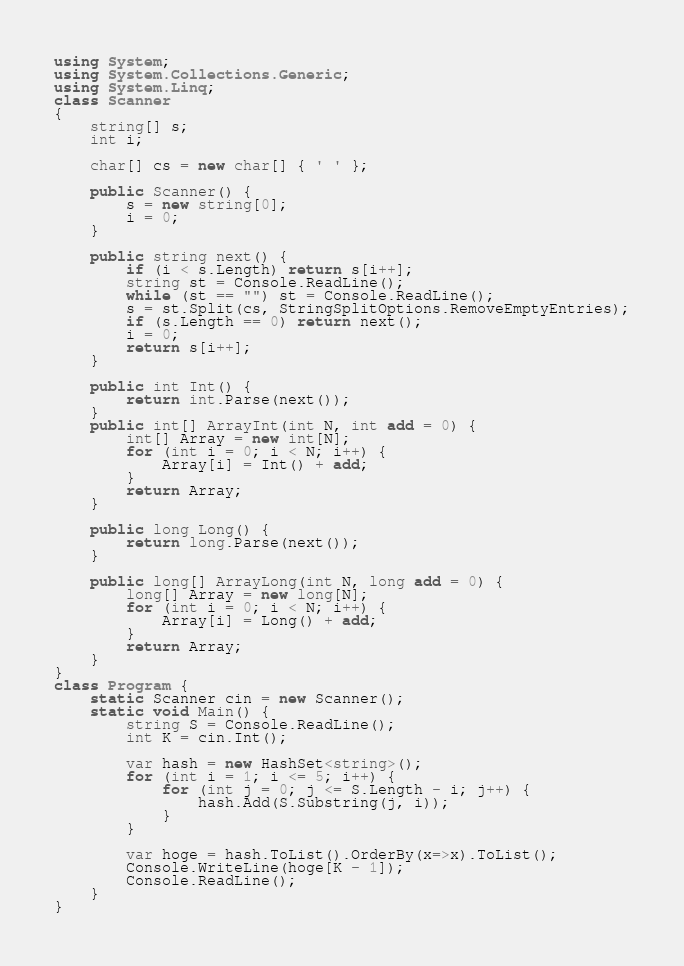Convert code to text. <code><loc_0><loc_0><loc_500><loc_500><_C#_>using System;
using System.Collections.Generic;
using System.Linq;
class Scanner
{
    string[] s;
    int i;

    char[] cs = new char[] { ' ' };

    public Scanner() {
        s = new string[0];
        i = 0;
    }

    public string next() {
        if (i < s.Length) return s[i++];
        string st = Console.ReadLine();
        while (st == "") st = Console.ReadLine();
        s = st.Split(cs, StringSplitOptions.RemoveEmptyEntries);
        if (s.Length == 0) return next();
        i = 0;
        return s[i++];
    }

    public int Int() {
        return int.Parse(next());
    }
    public int[] ArrayInt(int N, int add = 0) {
        int[] Array = new int[N];
        for (int i = 0; i < N; i++) {
            Array[i] = Int() + add;
        }
        return Array;
    }

    public long Long() {
        return long.Parse(next());
    }

    public long[] ArrayLong(int N, long add = 0) {
        long[] Array = new long[N];
        for (int i = 0; i < N; i++) {
            Array[i] = Long() + add;
        }
        return Array;
    }
}
class Program {
    static Scanner cin = new Scanner();
    static void Main() {
        string S = Console.ReadLine();
        int K = cin.Int();

        var hash = new HashSet<string>();
        for (int i = 1; i <= 5; i++) {
            for (int j = 0; j <= S.Length - i; j++) {
                hash.Add(S.Substring(j, i));
            }
        }

        var hoge = hash.ToList().OrderBy(x=>x).ToList();
        Console.WriteLine(hoge[K - 1]);
        Console.ReadLine();
    }
}</code> 